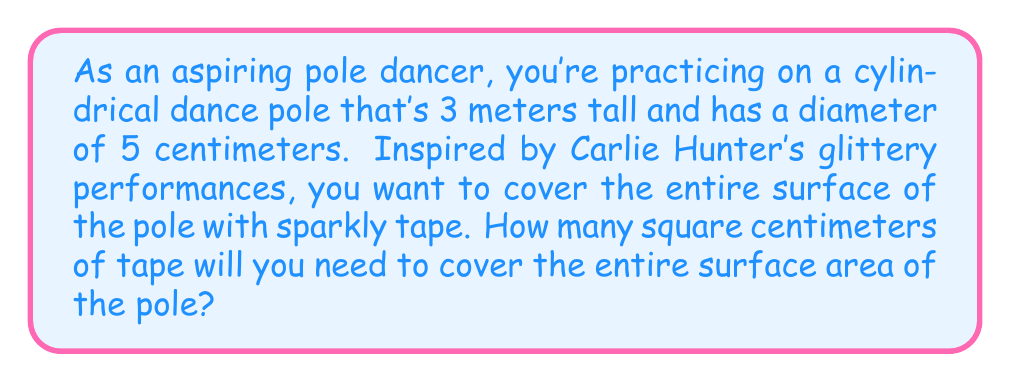Help me with this question. To solve this problem, we need to calculate the surface area of a cylinder. The surface area of a cylinder consists of two circular bases and the lateral surface area.

1. Calculate the radius of the pole:
   Diameter = 5 cm, so radius = 5/2 = 2.5 cm

2. Calculate the area of one circular base:
   $$A_{base} = \pi r^2 = \pi (2.5\text{ cm})^2 = 6.25\pi \text{ cm}^2$$

3. Calculate the lateral surface area:
   First, convert the height to centimeters: 3 m = 300 cm
   $$A_{lateral} = 2\pi rh = 2\pi (2.5\text{ cm})(300\text{ cm}) = 1500\pi \text{ cm}^2$$

4. Calculate the total surface area:
   $$A_{total} = 2A_{base} + A_{lateral} = 2(6.25\pi \text{ cm}^2) + 1500\pi \text{ cm}^2 = 1512.5\pi \text{ cm}^2$$

5. Evaluate the final result:
   $$A_{total} = 1512.5\pi \approx 4750.7 \text{ cm}^2$$

Therefore, you'll need approximately 4750.7 square centimeters of sparkly tape to cover the entire surface of the pole.
Answer: $4750.7 \text{ cm}^2$ 